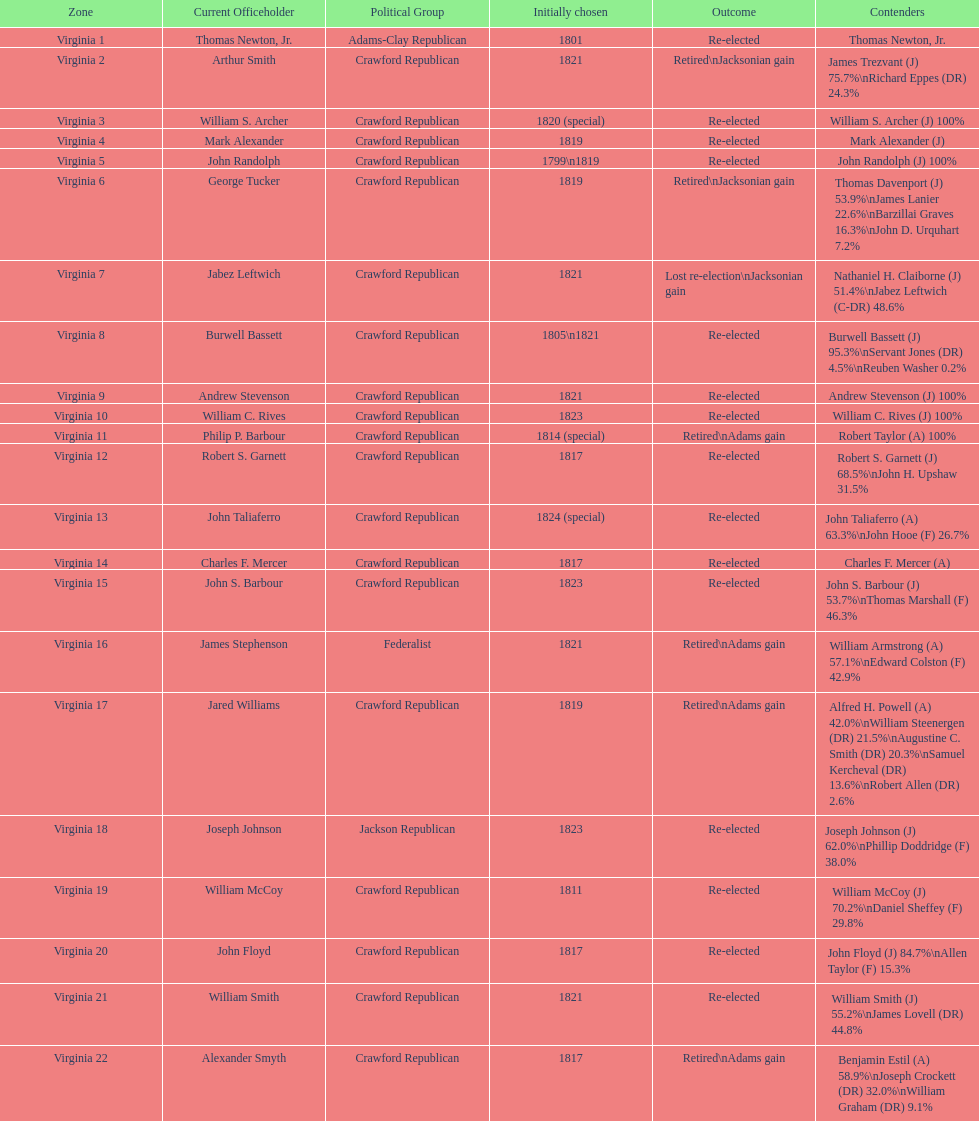Which jacksonian candidates got at least 76% of the vote in their races? Arthur Smith. 